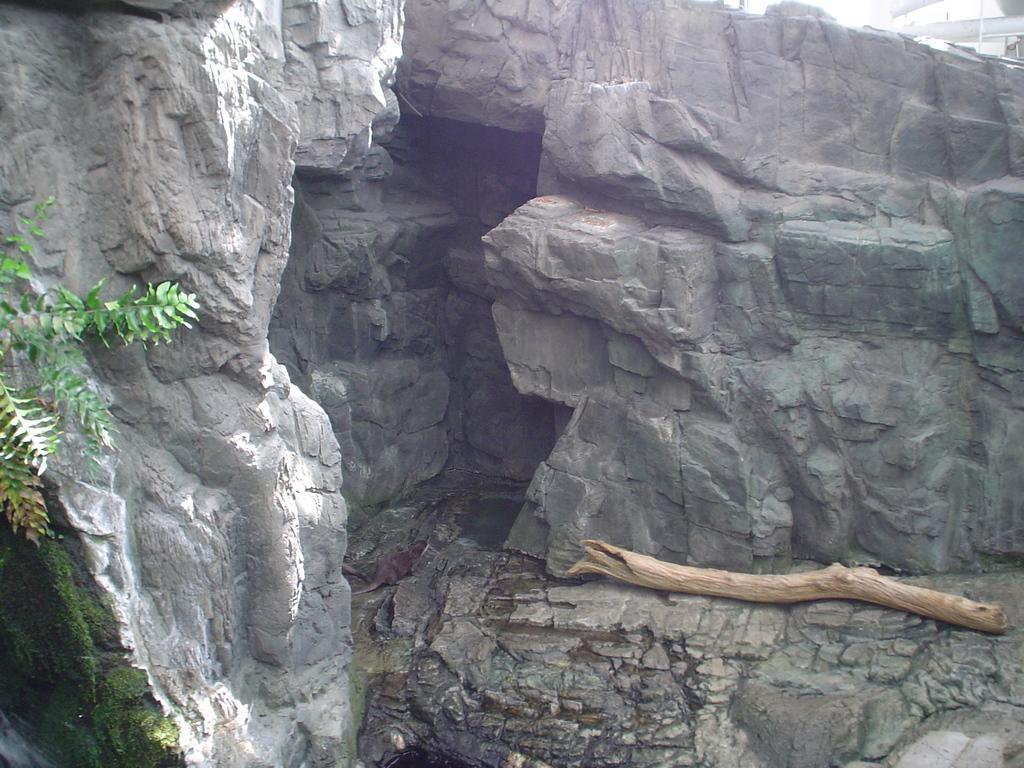In one or two sentences, can you explain what this image depicts? In the picture we can see some rocks, hills near to it, we can see some plant and some mold to the rocks and some tree stick on it. 